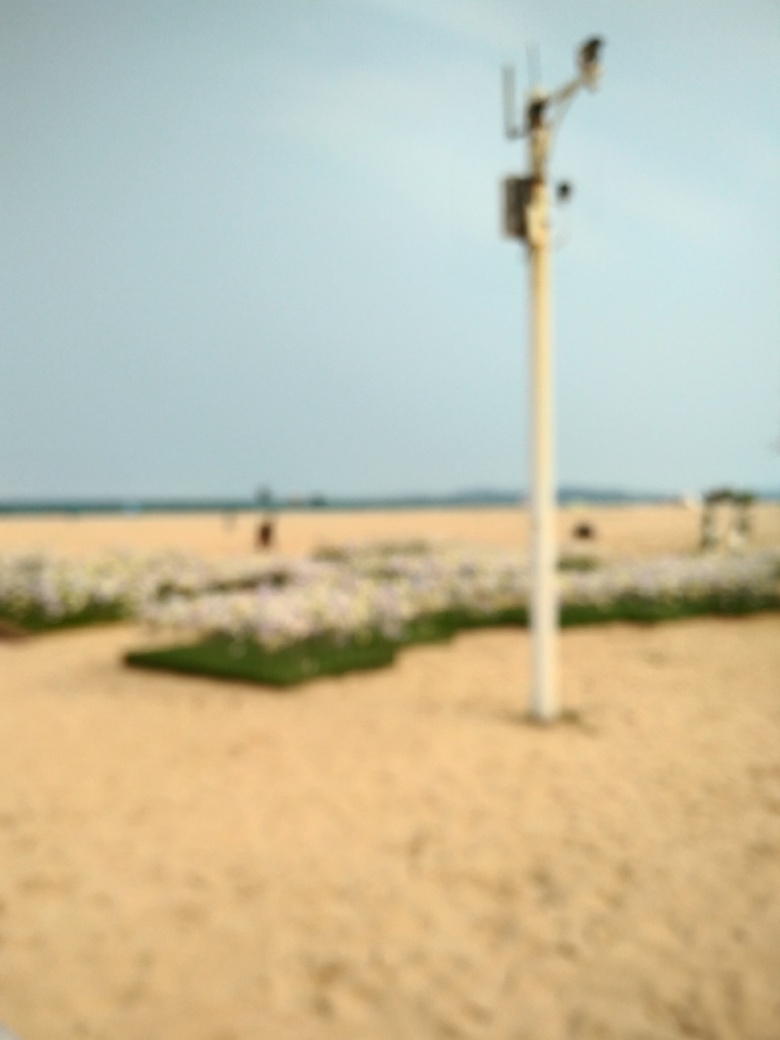Is the image free from blurriness? The image exhibits a noticeable level of blurriness, impacting the sharpness and clarity typically expected from a photograph. Details within the scene such as the exact shapes and colors are obscured due to the lack of focus throughout the image. 